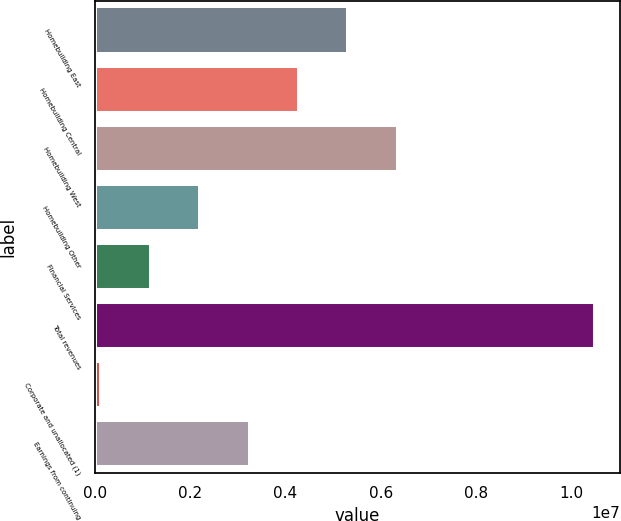<chart> <loc_0><loc_0><loc_500><loc_500><bar_chart><fcel>Homebuilding East<fcel>Homebuilding Central<fcel>Homebuilding West<fcel>Homebuilding Other<fcel>Financial Services<fcel>Total revenues<fcel>Corporate and unallocated (1)<fcel>Earnings from continuing<nl><fcel>5.32134e+06<fcel>4.28542e+06<fcel>6.35727e+06<fcel>2.21357e+06<fcel>1.17765e+06<fcel>1.0501e+07<fcel>141722<fcel>3.2495e+06<nl></chart> 